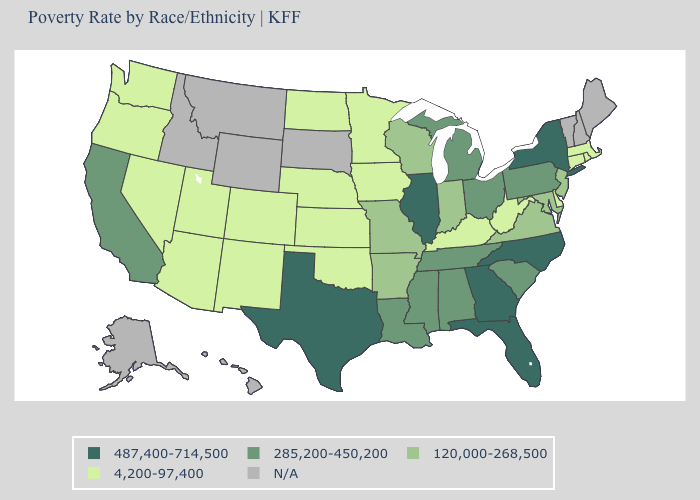Among the states that border Connecticut , does New York have the lowest value?
Write a very short answer. No. What is the value of South Carolina?
Quick response, please. 285,200-450,200. Name the states that have a value in the range N/A?
Short answer required. Alaska, Hawaii, Idaho, Maine, Montana, New Hampshire, South Dakota, Vermont, Wyoming. Does the map have missing data?
Give a very brief answer. Yes. Does North Carolina have the highest value in the South?
Keep it brief. Yes. How many symbols are there in the legend?
Give a very brief answer. 5. What is the lowest value in the USA?
Quick response, please. 4,200-97,400. What is the lowest value in the USA?
Be succinct. 4,200-97,400. How many symbols are there in the legend?
Keep it brief. 5. What is the value of Washington?
Be succinct. 4,200-97,400. Name the states that have a value in the range 120,000-268,500?
Be succinct. Arkansas, Indiana, Maryland, Missouri, New Jersey, Virginia, Wisconsin. Does North Dakota have the lowest value in the USA?
Concise answer only. Yes. What is the value of New York?
Keep it brief. 487,400-714,500. Name the states that have a value in the range N/A?
Quick response, please. Alaska, Hawaii, Idaho, Maine, Montana, New Hampshire, South Dakota, Vermont, Wyoming. 